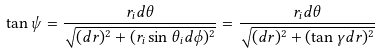Convert formula to latex. <formula><loc_0><loc_0><loc_500><loc_500>\tan { \psi } = \frac { r _ { i } d \theta } { \sqrt { ( d r ) ^ { 2 } + ( r _ { i } \sin { \theta _ { i } } d \phi ) ^ { 2 } } } = \frac { r _ { i } d \theta } { \sqrt { ( d r ) ^ { 2 } + ( \tan { \gamma } d r ) ^ { 2 } } }</formula> 